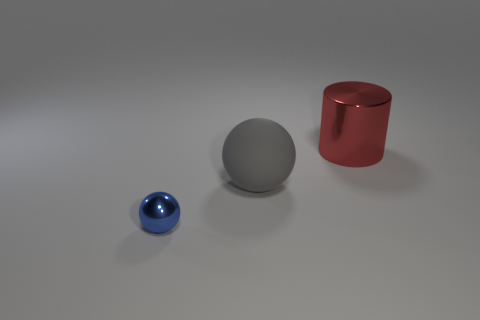Can you describe the texture and material properties of the objects? Certainly! The objects depicted appear to have a matte finish. The blue ball seems to have a smooth surface characteristic of a metallic material, reflecting light softly. The gray sphere and red cylinder also have a smooth metallic texture, which suggests that all objects are made from similar materials, with the difference being in their colors and shapes. 